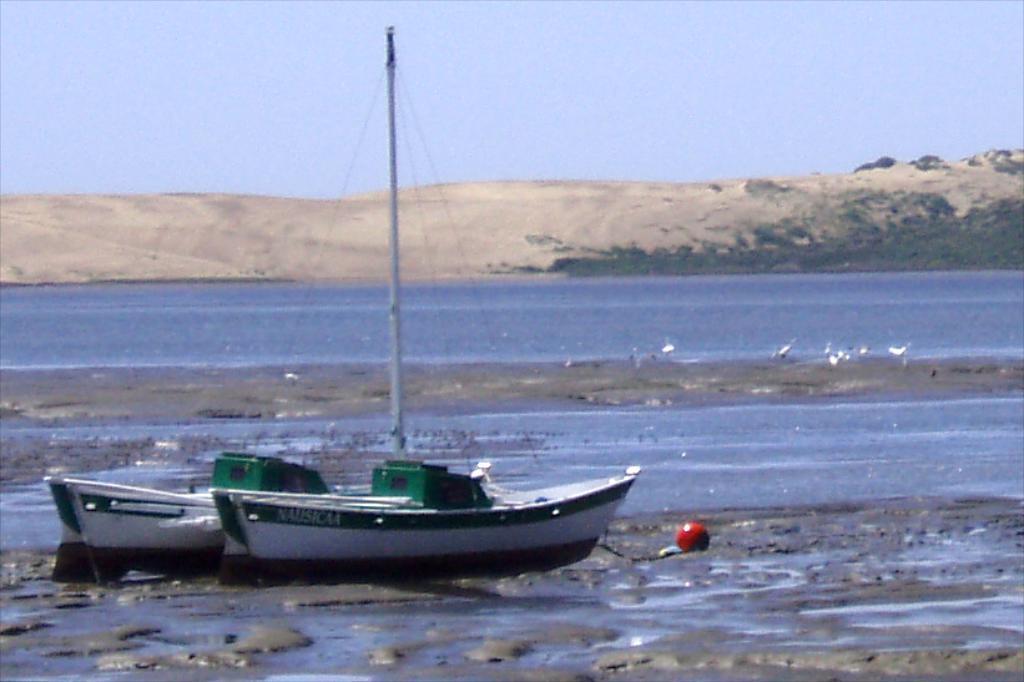Can you describe this image briefly? In this image there is water and we can see a boat on the water. There are birds. In the background there are hills and sky. 